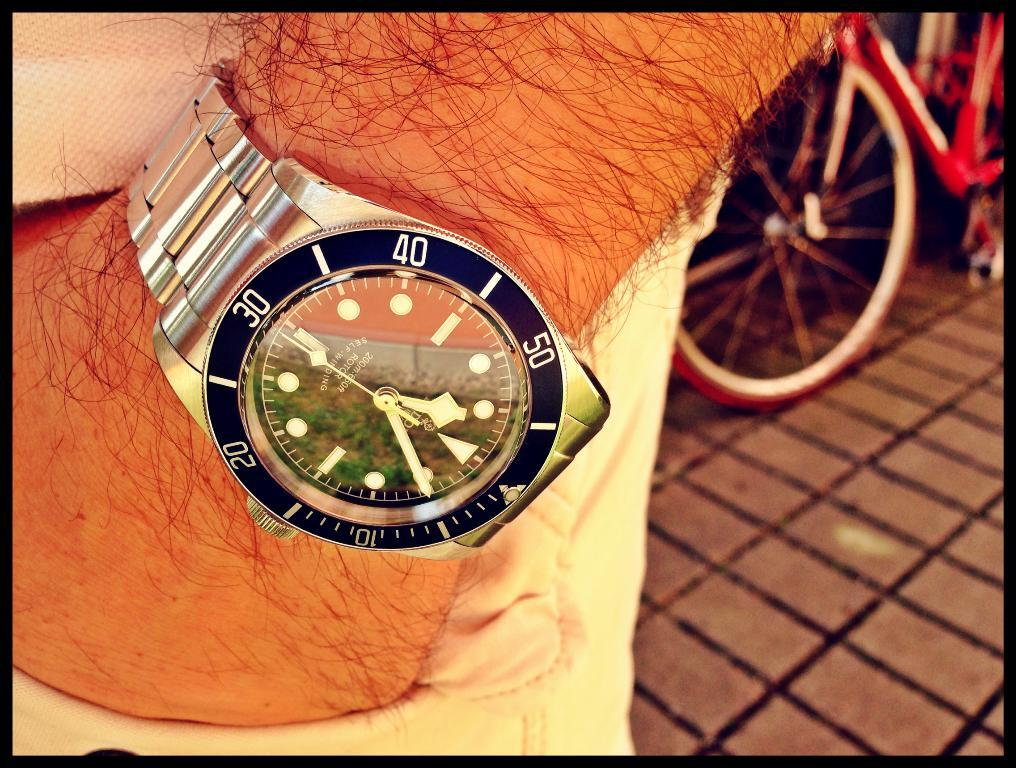What object is present on a body part in the image? There is a wrist watch in the image, and it is on a hand. What mode of transportation is visible in the image? There is a cycle in the image. Where is the cycle located in the image? The cycle is on a surface in the image. What type of nut can be seen being cracked open in the image? There is no nut present in the image. What type of waste material can be seen being disposed of in the image? There is no waste material present in the image. What type of twig can be seen being used as a tool in the image? There is no twig present in the image. 